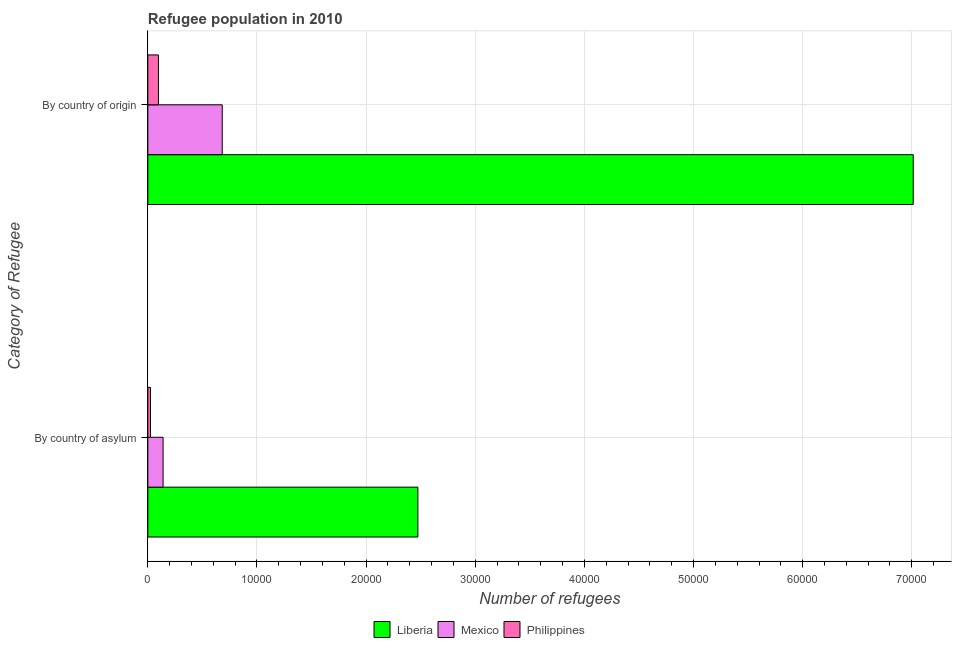Are the number of bars on each tick of the Y-axis equal?
Provide a succinct answer. Yes. How many bars are there on the 2nd tick from the top?
Offer a terse response. 3. What is the label of the 2nd group of bars from the top?
Provide a short and direct response. By country of asylum. What is the number of refugees by country of origin in Liberia?
Your answer should be very brief. 7.01e+04. Across all countries, what is the maximum number of refugees by country of origin?
Offer a very short reply. 7.01e+04. Across all countries, what is the minimum number of refugees by country of asylum?
Provide a succinct answer. 243. In which country was the number of refugees by country of origin maximum?
Your answer should be compact. Liberia. What is the total number of refugees by country of asylum in the graph?
Make the answer very short. 2.64e+04. What is the difference between the number of refugees by country of asylum in Mexico and that in Philippines?
Make the answer very short. 1152. What is the difference between the number of refugees by country of origin in Philippines and the number of refugees by country of asylum in Liberia?
Make the answer very short. -2.38e+04. What is the average number of refugees by country of asylum per country?
Give a very brief answer. 8793.67. What is the difference between the number of refugees by country of asylum and number of refugees by country of origin in Mexico?
Give a very brief answer. -5421. In how many countries, is the number of refugees by country of asylum greater than 6000 ?
Keep it short and to the point. 1. What is the ratio of the number of refugees by country of origin in Mexico to that in Liberia?
Ensure brevity in your answer.  0.1. What does the 2nd bar from the top in By country of asylum represents?
Offer a very short reply. Mexico. What does the 1st bar from the bottom in By country of origin represents?
Keep it short and to the point. Liberia. Are all the bars in the graph horizontal?
Your response must be concise. Yes. How many countries are there in the graph?
Offer a terse response. 3. What is the difference between two consecutive major ticks on the X-axis?
Make the answer very short. 10000. Are the values on the major ticks of X-axis written in scientific E-notation?
Ensure brevity in your answer.  No. Does the graph contain grids?
Provide a succinct answer. Yes. Where does the legend appear in the graph?
Make the answer very short. Bottom center. How are the legend labels stacked?
Offer a very short reply. Horizontal. What is the title of the graph?
Offer a terse response. Refugee population in 2010. What is the label or title of the X-axis?
Make the answer very short. Number of refugees. What is the label or title of the Y-axis?
Make the answer very short. Category of Refugee. What is the Number of refugees in Liberia in By country of asylum?
Ensure brevity in your answer.  2.47e+04. What is the Number of refugees in Mexico in By country of asylum?
Offer a terse response. 1395. What is the Number of refugees of Philippines in By country of asylum?
Offer a very short reply. 243. What is the Number of refugees in Liberia in By country of origin?
Provide a succinct answer. 7.01e+04. What is the Number of refugees in Mexico in By country of origin?
Your answer should be compact. 6816. What is the Number of refugees of Philippines in By country of origin?
Provide a succinct answer. 970. Across all Category of Refugee, what is the maximum Number of refugees in Liberia?
Your response must be concise. 7.01e+04. Across all Category of Refugee, what is the maximum Number of refugees in Mexico?
Your answer should be very brief. 6816. Across all Category of Refugee, what is the maximum Number of refugees in Philippines?
Ensure brevity in your answer.  970. Across all Category of Refugee, what is the minimum Number of refugees in Liberia?
Provide a short and direct response. 2.47e+04. Across all Category of Refugee, what is the minimum Number of refugees of Mexico?
Make the answer very short. 1395. Across all Category of Refugee, what is the minimum Number of refugees in Philippines?
Offer a terse response. 243. What is the total Number of refugees of Liberia in the graph?
Make the answer very short. 9.49e+04. What is the total Number of refugees in Mexico in the graph?
Provide a succinct answer. 8211. What is the total Number of refugees of Philippines in the graph?
Provide a short and direct response. 1213. What is the difference between the Number of refugees in Liberia in By country of asylum and that in By country of origin?
Provide a succinct answer. -4.54e+04. What is the difference between the Number of refugees in Mexico in By country of asylum and that in By country of origin?
Your response must be concise. -5421. What is the difference between the Number of refugees of Philippines in By country of asylum and that in By country of origin?
Offer a very short reply. -727. What is the difference between the Number of refugees of Liberia in By country of asylum and the Number of refugees of Mexico in By country of origin?
Provide a short and direct response. 1.79e+04. What is the difference between the Number of refugees of Liberia in By country of asylum and the Number of refugees of Philippines in By country of origin?
Ensure brevity in your answer.  2.38e+04. What is the difference between the Number of refugees in Mexico in By country of asylum and the Number of refugees in Philippines in By country of origin?
Your answer should be very brief. 425. What is the average Number of refugees of Liberia per Category of Refugee?
Provide a short and direct response. 4.74e+04. What is the average Number of refugees of Mexico per Category of Refugee?
Your answer should be compact. 4105.5. What is the average Number of refugees of Philippines per Category of Refugee?
Give a very brief answer. 606.5. What is the difference between the Number of refugees of Liberia and Number of refugees of Mexico in By country of asylum?
Provide a succinct answer. 2.33e+04. What is the difference between the Number of refugees in Liberia and Number of refugees in Philippines in By country of asylum?
Your response must be concise. 2.45e+04. What is the difference between the Number of refugees in Mexico and Number of refugees in Philippines in By country of asylum?
Keep it short and to the point. 1152. What is the difference between the Number of refugees in Liberia and Number of refugees in Mexico in By country of origin?
Give a very brief answer. 6.33e+04. What is the difference between the Number of refugees in Liberia and Number of refugees in Philippines in By country of origin?
Keep it short and to the point. 6.92e+04. What is the difference between the Number of refugees in Mexico and Number of refugees in Philippines in By country of origin?
Your response must be concise. 5846. What is the ratio of the Number of refugees in Liberia in By country of asylum to that in By country of origin?
Offer a terse response. 0.35. What is the ratio of the Number of refugees of Mexico in By country of asylum to that in By country of origin?
Offer a terse response. 0.2. What is the ratio of the Number of refugees in Philippines in By country of asylum to that in By country of origin?
Offer a terse response. 0.25. What is the difference between the highest and the second highest Number of refugees in Liberia?
Provide a succinct answer. 4.54e+04. What is the difference between the highest and the second highest Number of refugees in Mexico?
Provide a succinct answer. 5421. What is the difference between the highest and the second highest Number of refugees in Philippines?
Keep it short and to the point. 727. What is the difference between the highest and the lowest Number of refugees in Liberia?
Your answer should be very brief. 4.54e+04. What is the difference between the highest and the lowest Number of refugees in Mexico?
Keep it short and to the point. 5421. What is the difference between the highest and the lowest Number of refugees of Philippines?
Ensure brevity in your answer.  727. 